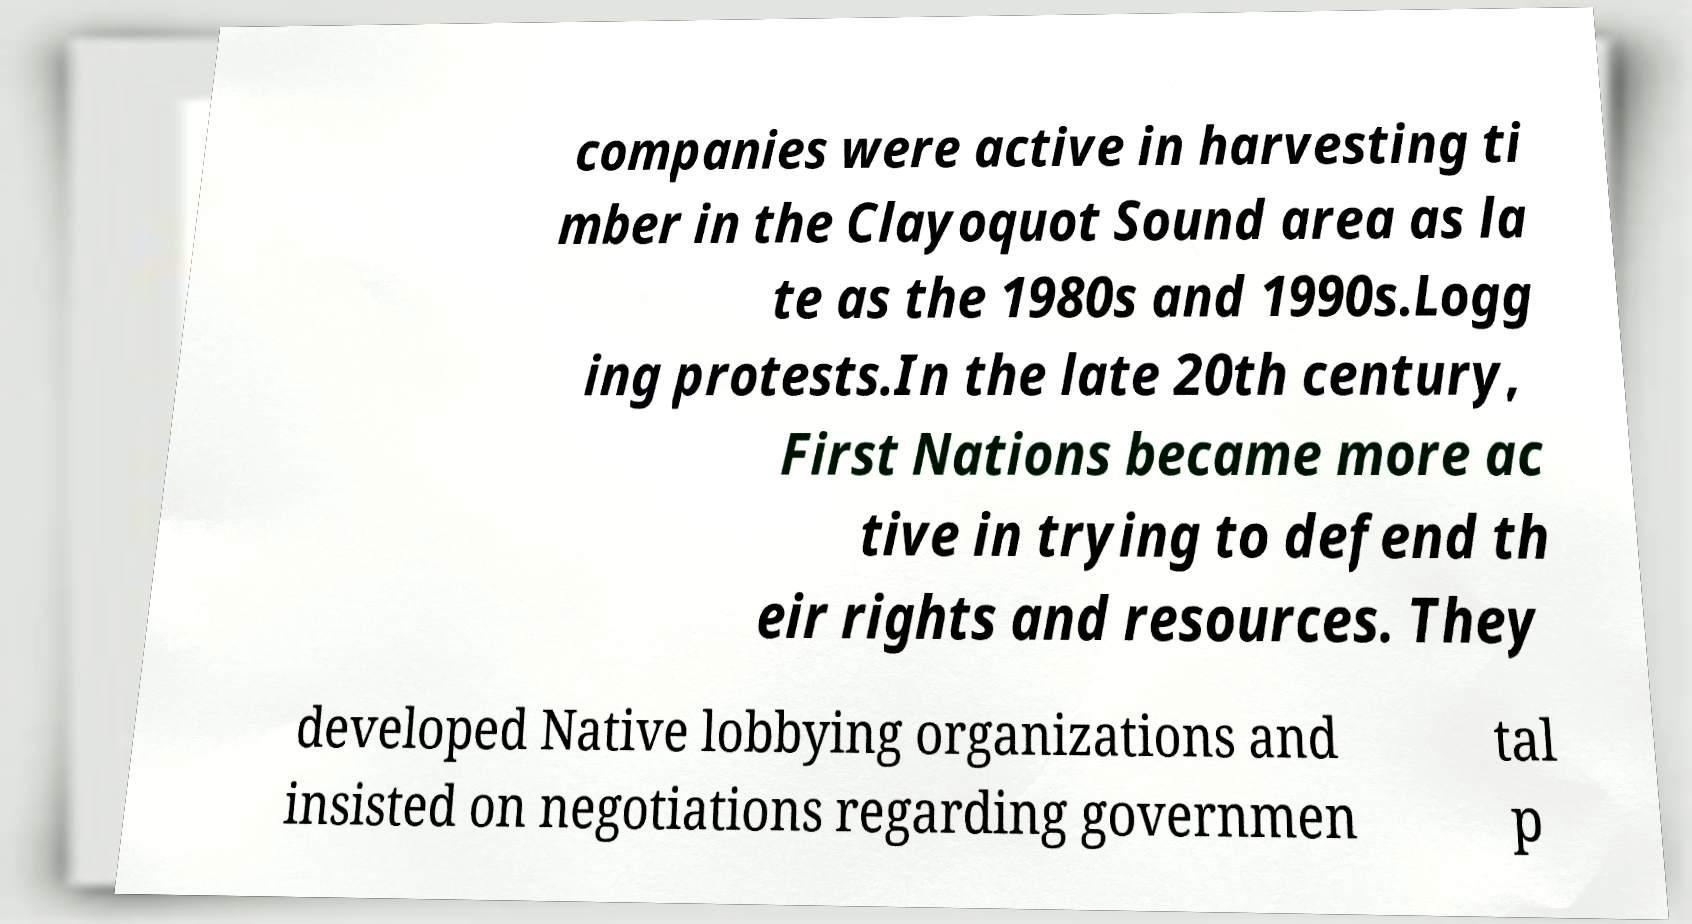There's text embedded in this image that I need extracted. Can you transcribe it verbatim? companies were active in harvesting ti mber in the Clayoquot Sound area as la te as the 1980s and 1990s.Logg ing protests.In the late 20th century, First Nations became more ac tive in trying to defend th eir rights and resources. They developed Native lobbying organizations and insisted on negotiations regarding governmen tal p 